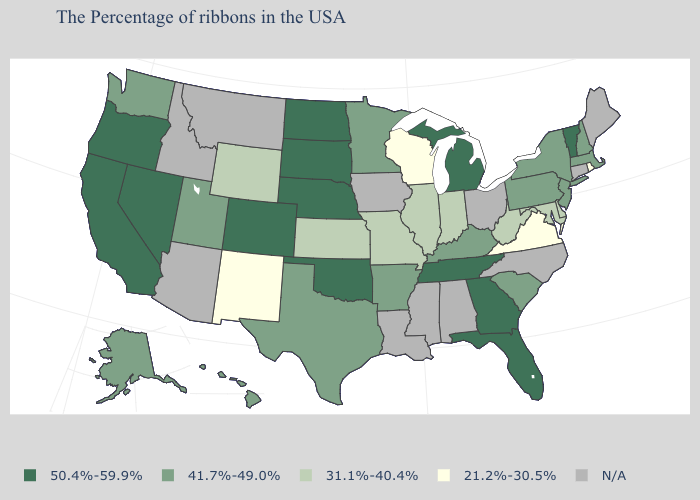Name the states that have a value in the range 31.1%-40.4%?
Give a very brief answer. Delaware, Maryland, West Virginia, Indiana, Illinois, Missouri, Kansas, Wyoming. What is the value of Alaska?
Concise answer only. 41.7%-49.0%. What is the value of New York?
Short answer required. 41.7%-49.0%. What is the highest value in the USA?
Be succinct. 50.4%-59.9%. What is the value of Texas?
Give a very brief answer. 41.7%-49.0%. How many symbols are there in the legend?
Give a very brief answer. 5. Name the states that have a value in the range 21.2%-30.5%?
Give a very brief answer. Rhode Island, Virginia, Wisconsin, New Mexico. What is the lowest value in the West?
Give a very brief answer. 21.2%-30.5%. Among the states that border Virginia , does Maryland have the lowest value?
Keep it brief. Yes. What is the value of West Virginia?
Write a very short answer. 31.1%-40.4%. Among the states that border Maryland , which have the lowest value?
Answer briefly. Virginia. Does Missouri have the highest value in the MidWest?
Keep it brief. No. What is the lowest value in states that border Georgia?
Write a very short answer. 41.7%-49.0%. Does Texas have the highest value in the South?
Answer briefly. No. 